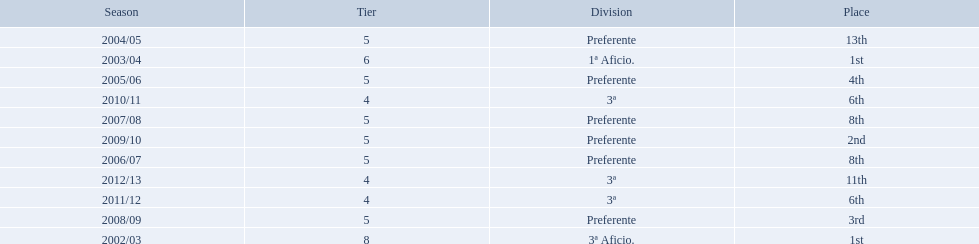Which seasons were played in tier four? 2010/11, 2011/12, 2012/13. Of these seasons, which resulted in 6th place? 2010/11, 2011/12. Parse the table in full. {'header': ['Season', 'Tier', 'Division', 'Place'], 'rows': [['2004/05', '5', 'Preferente', '13th'], ['2003/04', '6', '1ª Aficio.', '1st'], ['2005/06', '5', 'Preferente', '4th'], ['2010/11', '4', '3ª', '6th'], ['2007/08', '5', 'Preferente', '8th'], ['2009/10', '5', 'Preferente', '2nd'], ['2006/07', '5', 'Preferente', '8th'], ['2012/13', '4', '3ª', '11th'], ['2011/12', '4', '3ª', '6th'], ['2008/09', '5', 'Preferente', '3rd'], ['2002/03', '8', '3ª Aficio.', '1st']]} Which of the remaining happened last? 2011/12. 